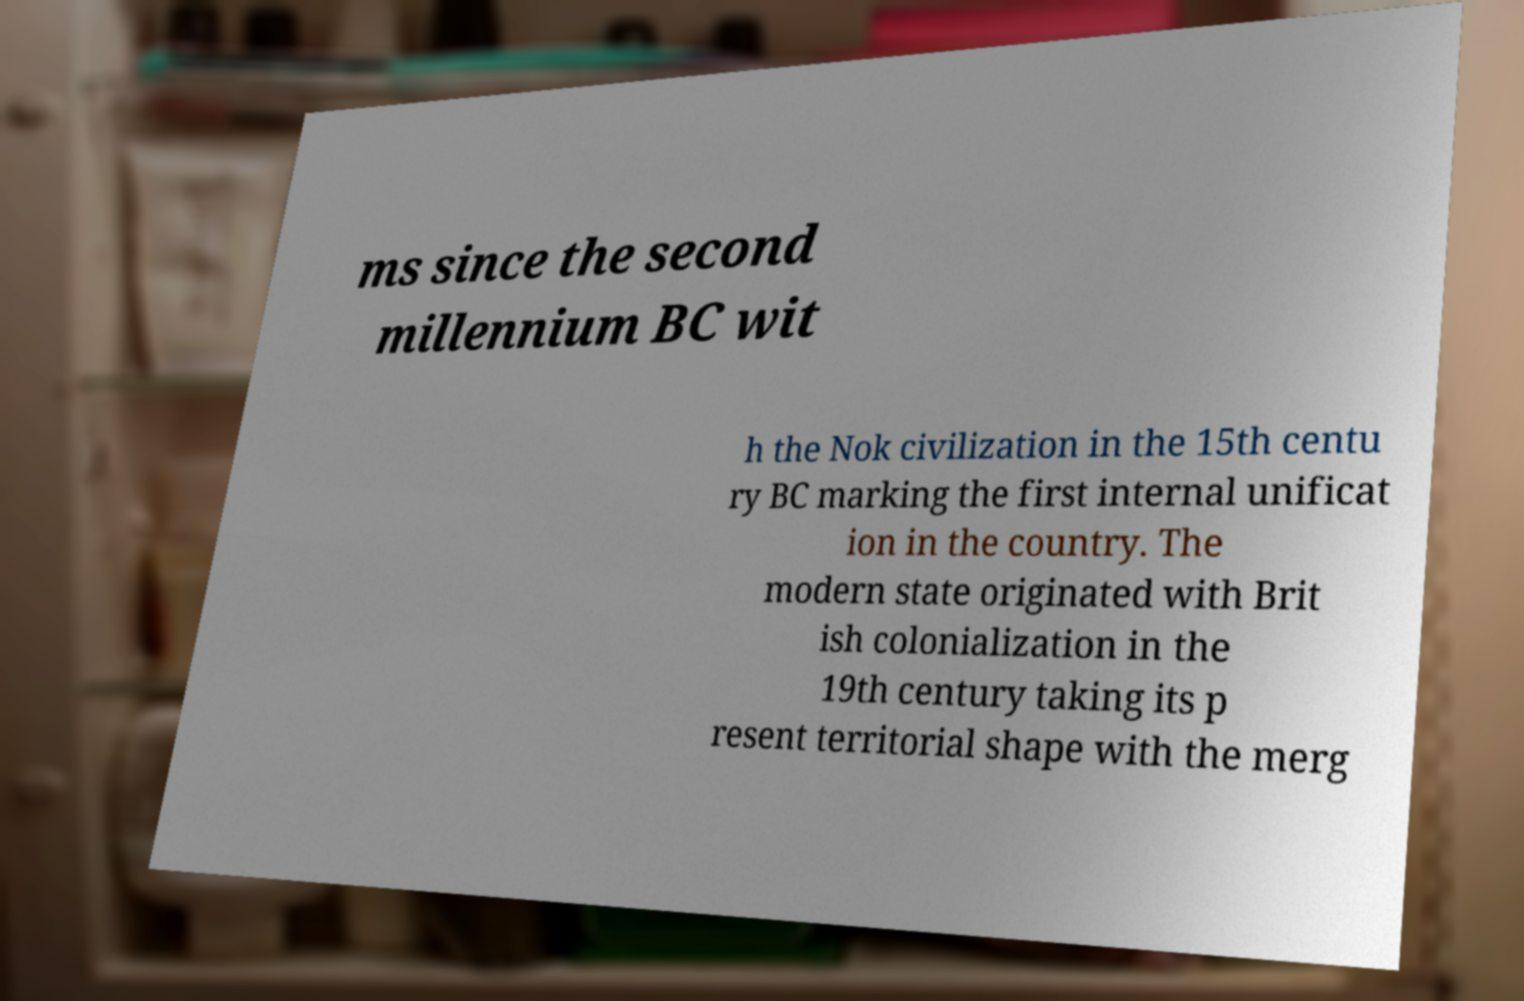What messages or text are displayed in this image? I need them in a readable, typed format. ms since the second millennium BC wit h the Nok civilization in the 15th centu ry BC marking the first internal unificat ion in the country. The modern state originated with Brit ish colonialization in the 19th century taking its p resent territorial shape with the merg 